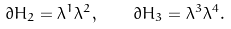<formula> <loc_0><loc_0><loc_500><loc_500>\partial H _ { 2 } = \lambda ^ { 1 } \lambda ^ { 2 } , \quad \partial H _ { 3 } = \lambda ^ { 3 } \lambda ^ { 4 } .</formula> 